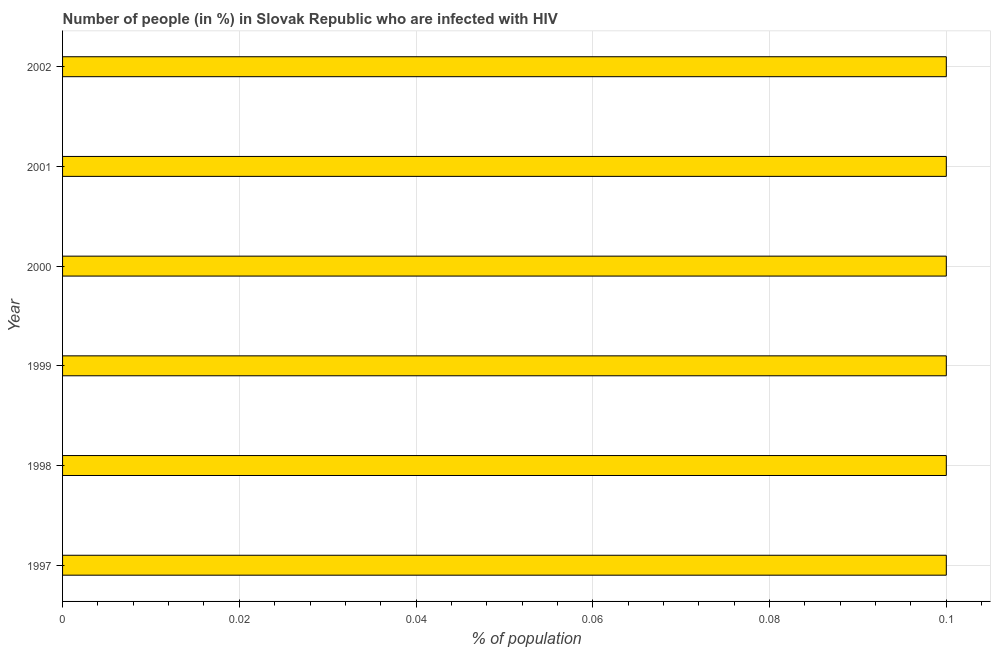Does the graph contain any zero values?
Offer a terse response. No. What is the title of the graph?
Provide a short and direct response. Number of people (in %) in Slovak Republic who are infected with HIV. What is the label or title of the X-axis?
Make the answer very short. % of population. What is the label or title of the Y-axis?
Provide a short and direct response. Year. What is the number of people infected with hiv in 1999?
Offer a very short reply. 0.1. Across all years, what is the maximum number of people infected with hiv?
Your answer should be very brief. 0.1. What is the average number of people infected with hiv per year?
Make the answer very short. 0.1. Do a majority of the years between 2002 and 2000 (inclusive) have number of people infected with hiv greater than 0.096 %?
Offer a very short reply. Yes. Is the number of people infected with hiv in 1998 less than that in 2002?
Offer a very short reply. No. Is the difference between the number of people infected with hiv in 1997 and 1999 greater than the difference between any two years?
Give a very brief answer. Yes. What is the difference between the highest and the second highest number of people infected with hiv?
Provide a succinct answer. 0. Is the sum of the number of people infected with hiv in 1997 and 2002 greater than the maximum number of people infected with hiv across all years?
Keep it short and to the point. Yes. What is the difference between the highest and the lowest number of people infected with hiv?
Provide a succinct answer. 0. In how many years, is the number of people infected with hiv greater than the average number of people infected with hiv taken over all years?
Provide a succinct answer. 6. Are the values on the major ticks of X-axis written in scientific E-notation?
Your answer should be very brief. No. What is the % of population in 1997?
Your answer should be very brief. 0.1. What is the % of population of 2001?
Your response must be concise. 0.1. What is the difference between the % of population in 1997 and 1999?
Provide a succinct answer. 0. What is the difference between the % of population in 1997 and 2000?
Offer a terse response. 0. What is the difference between the % of population in 1997 and 2002?
Your answer should be compact. 0. What is the difference between the % of population in 1998 and 2001?
Provide a succinct answer. 0. What is the difference between the % of population in 1999 and 2000?
Give a very brief answer. 0. What is the difference between the % of population in 2000 and 2001?
Ensure brevity in your answer.  0. What is the difference between the % of population in 2000 and 2002?
Provide a succinct answer. 0. What is the ratio of the % of population in 1997 to that in 1999?
Offer a very short reply. 1. What is the ratio of the % of population in 1997 to that in 2000?
Your answer should be very brief. 1. What is the ratio of the % of population in 1997 to that in 2001?
Your answer should be very brief. 1. What is the ratio of the % of population in 1998 to that in 2000?
Your answer should be compact. 1. What is the ratio of the % of population in 1998 to that in 2001?
Offer a terse response. 1. What is the ratio of the % of population in 1998 to that in 2002?
Your response must be concise. 1. What is the ratio of the % of population in 1999 to that in 2000?
Offer a terse response. 1. What is the ratio of the % of population in 1999 to that in 2002?
Provide a short and direct response. 1. What is the ratio of the % of population in 2000 to that in 2001?
Ensure brevity in your answer.  1. What is the ratio of the % of population in 2001 to that in 2002?
Your response must be concise. 1. 